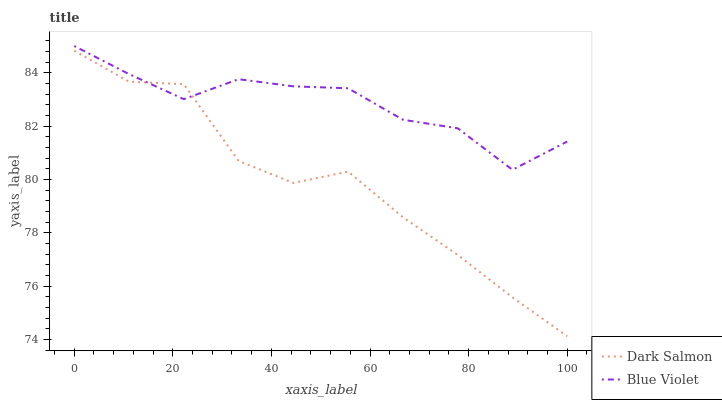Does Dark Salmon have the minimum area under the curve?
Answer yes or no. Yes. Does Blue Violet have the maximum area under the curve?
Answer yes or no. Yes. Does Blue Violet have the minimum area under the curve?
Answer yes or no. No. Is Blue Violet the smoothest?
Answer yes or no. Yes. Is Dark Salmon the roughest?
Answer yes or no. Yes. Is Blue Violet the roughest?
Answer yes or no. No. Does Dark Salmon have the lowest value?
Answer yes or no. Yes. Does Blue Violet have the lowest value?
Answer yes or no. No. Does Blue Violet have the highest value?
Answer yes or no. Yes. Does Dark Salmon intersect Blue Violet?
Answer yes or no. Yes. Is Dark Salmon less than Blue Violet?
Answer yes or no. No. Is Dark Salmon greater than Blue Violet?
Answer yes or no. No. 